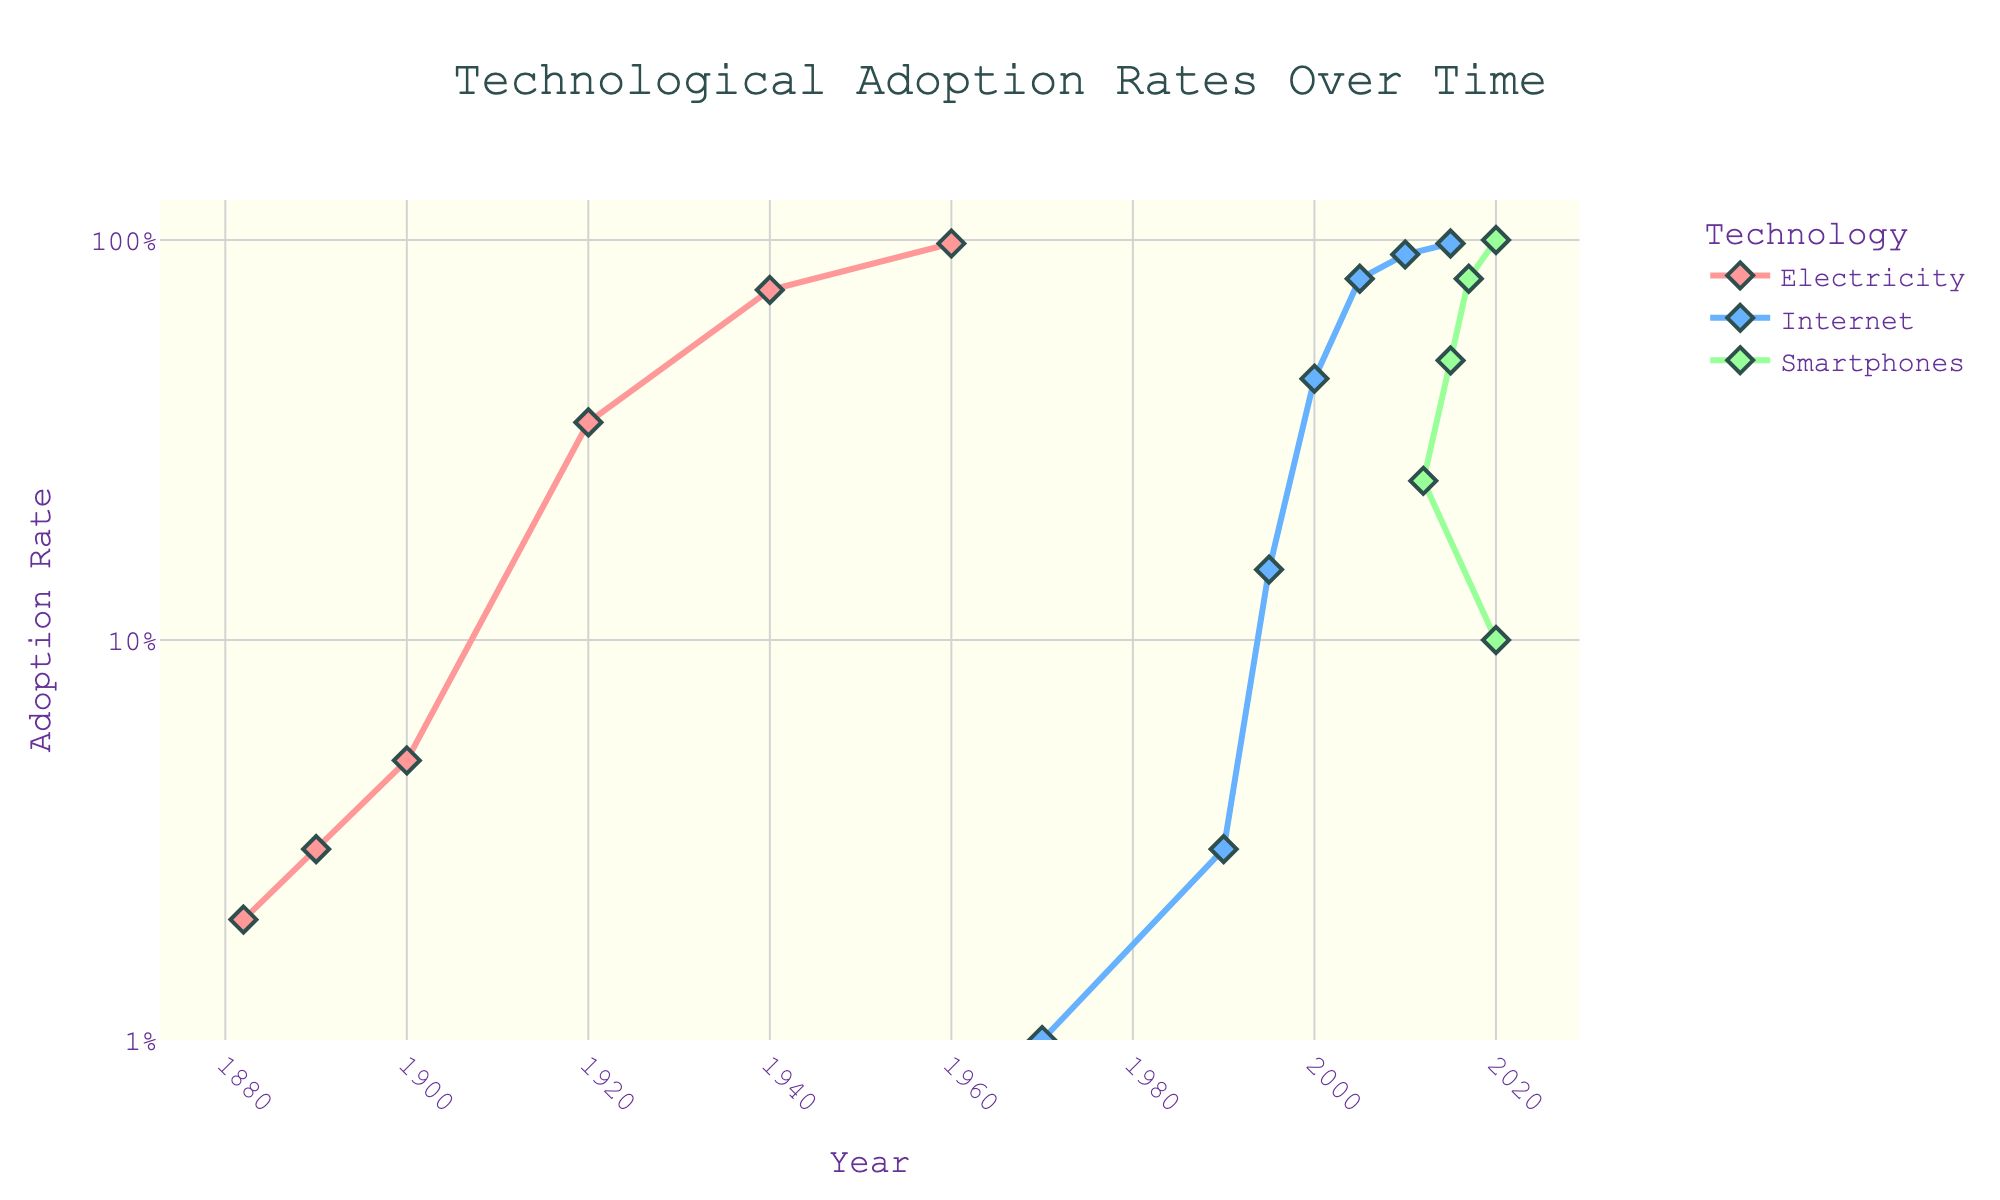What is the title of the figure? The title is typically placed at the top of the figure. In this case, it says "Technological Adoption Rates Over Time".
Answer: Technological Adoption Rates Over Time How many technologies are represented in the figure? The legend at the bottom right of the figure lists the different technologies. Here, there are three: Electricity, Internet, Smartphones.
Answer: Three Which technology had the highest adoption rate in 1995? By looking at the 1995 data points for all technologies, we find that the Internet is the only one shown and its adoption rate is at 0.15 (15%).
Answer: Internet What is the color used to represent the Internet? The lines and markers representing the Internet are blue. This can be seen in the legend and the plot lines.
Answer: Blue In what year did smartphones first reach a 50% adoption rate? By following the data points for Smartphones, we see that they hit a 50% adoption rate around 2015.
Answer: 2015 Compare the adoption rate of Smartphones and the Internet in the year 2000. Which one was higher? Looking at the data for the year 2000, the Internet had an adoption rate of 45% and Smartphones had no data points shown, indicating less than 10%. Thus, Internet had a higher adoption rate.
Answer: Internet What was the adoption rate of electricity in 1940? The graph's data points for Electricity show a value at 1940 and it is at 75%.
Answer: 75% How long did it take for the Internet to reach 80% adoption from its first appearance in 1970? First identify the years and adoption rates: 1970 (1%) to 2005 (80%). That timeframe is from 1970 to 2005.
Answer: 35 years What technology shows the fastest adoption rate upon introduction, based on the data trend? Smartphones show a rapid increase from 10% in 2010 to nearly 100% in 2020. This quick rise in adoption rate indicates the fastest adoption curve.
Answer: Smartphones Which decade saw the most significant increase in electricity adoption rates? Observing the slope of the lines, the most notable rise for electricity occurs between 1920 and 1940, going from 35% to 75%.
Answer: 1920s to 1930s 